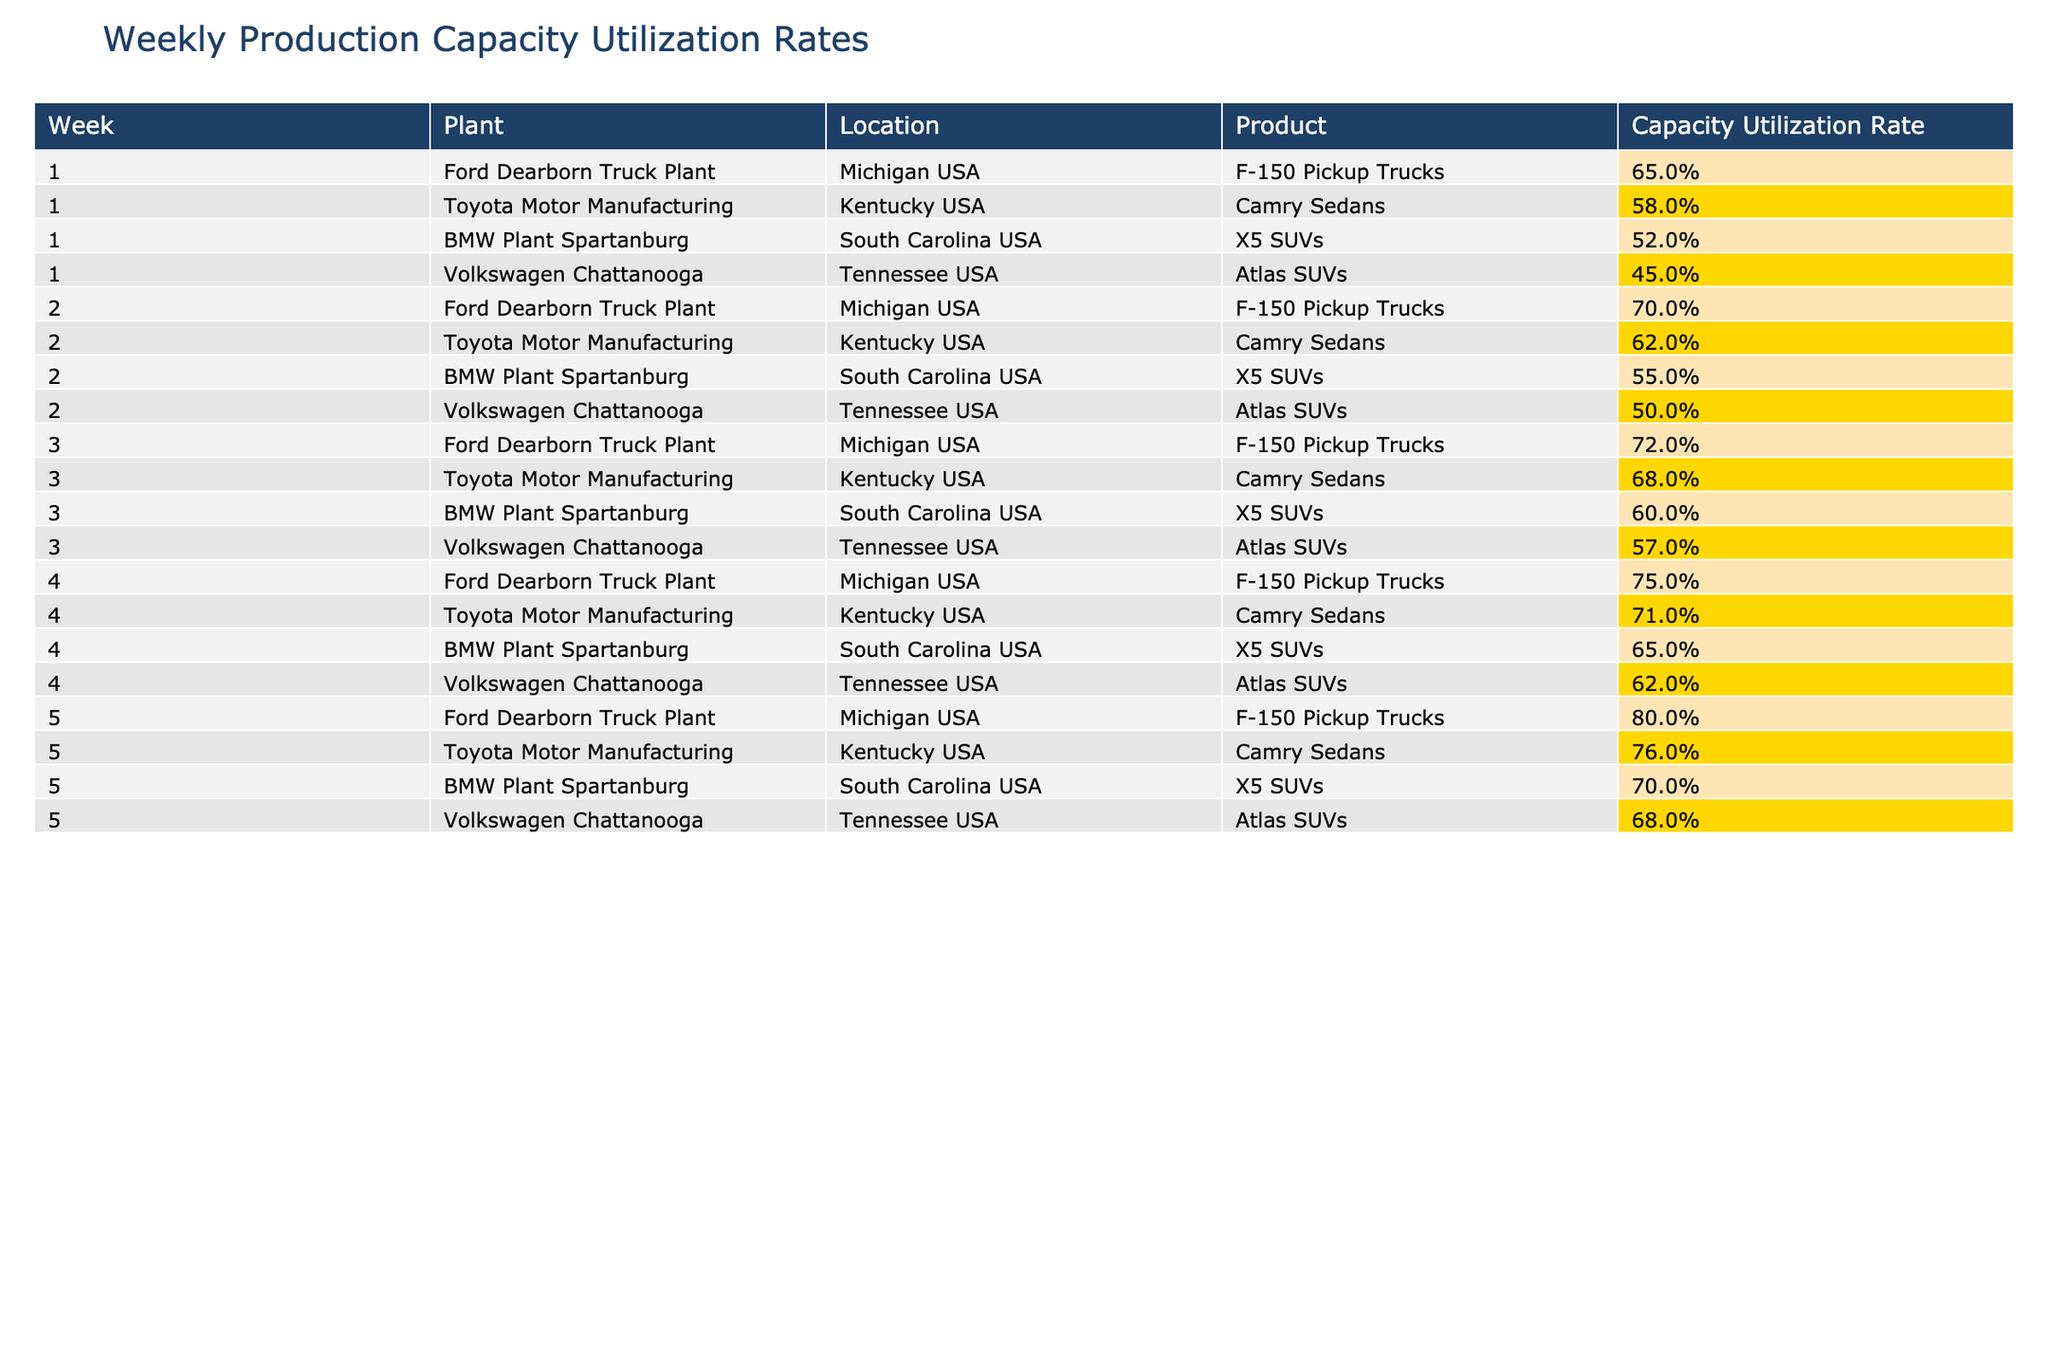What was the capacity utilization rate for the Ford Dearborn Truck Plant in week 3? In week 3, the table shows that the capacity utilization rate for the Ford Dearborn Truck Plant was 72%.
Answer: 72% Which plant had the highest capacity utilization rate in week 5? In week 5, the table indicates that the Ford Dearborn Truck Plant had the highest capacity utilization rate at 80%.
Answer: Ford Dearborn Truck Plant What is the average capacity utilization rate for the Toyota Motor Manufacturing plant across all weeks? The rates for the Toyota Motor Manufacturing plant over five weeks are 58%, 62%, 68%, 71%, and 76%. The sum is 58 + 62 + 68 + 71 + 76 = 335. Dividing by 5 gives 335 / 5 = 67%.
Answer: 67% Did the capacity utilization rate for BMW Plant Spartanburg increase from week 1 to week 4? In week 1, the rate was 52%, and in week 4, it increased to 65%. Therefore, it is true that there was an increase.
Answer: Yes What is the difference in capacity utilization rate between Volkswagen Chattanooga in week 1 and week 5? In week 1, the rate was 45%, whereas in week 5 it was 68%. The difference is 68 - 45 = 23%.
Answer: 23% Which product had the lowest maximum capacity utilization rate among all plants? The maximum rates for products are: F-150 Pickup Trucks 80%, Camry Sedans 76%, X5 SUVs 70%, and Atlas SUVs 68%. The lowest maximum is for Atlas SUVs at 68%.
Answer: Atlas SUVs What is the trend in capacity utilization rates for BMW Plant Spartanburg from week 1 to week 5? The rates over the weeks are 52%, 55%, 60%, 65%, and 70%. They are consistently increasing, indicating a positive trend in utilization rates.
Answer: Increasing Which plant consistently had utilization rates above 70% after week 2? After week 2, the Ford Dearborn Truck Plant’s rates were 72%, 75%, and 80%, which remained above 70%.
Answer: Ford Dearborn Truck Plant What is the median capacity utilization rate for all plants in week 4? In week 4, the rates are 75%, 71%, 65%, and 62%. Arranging them gives 62%, 65%, 71%, 75%. The median is the average of 65 and 71, which is (65 + 71) / 2 = 68%.
Answer: 68% Which plant saw the largest increase in capacity utilization rate from week 1 to week 5? The Ford Dearborn Truck Plant increased from 65% to 80%, an increase of 15%. The vehicle with the largest increase is the Ford Dearborn Truck Plant at 15%.
Answer: Ford Dearborn Truck Plant 